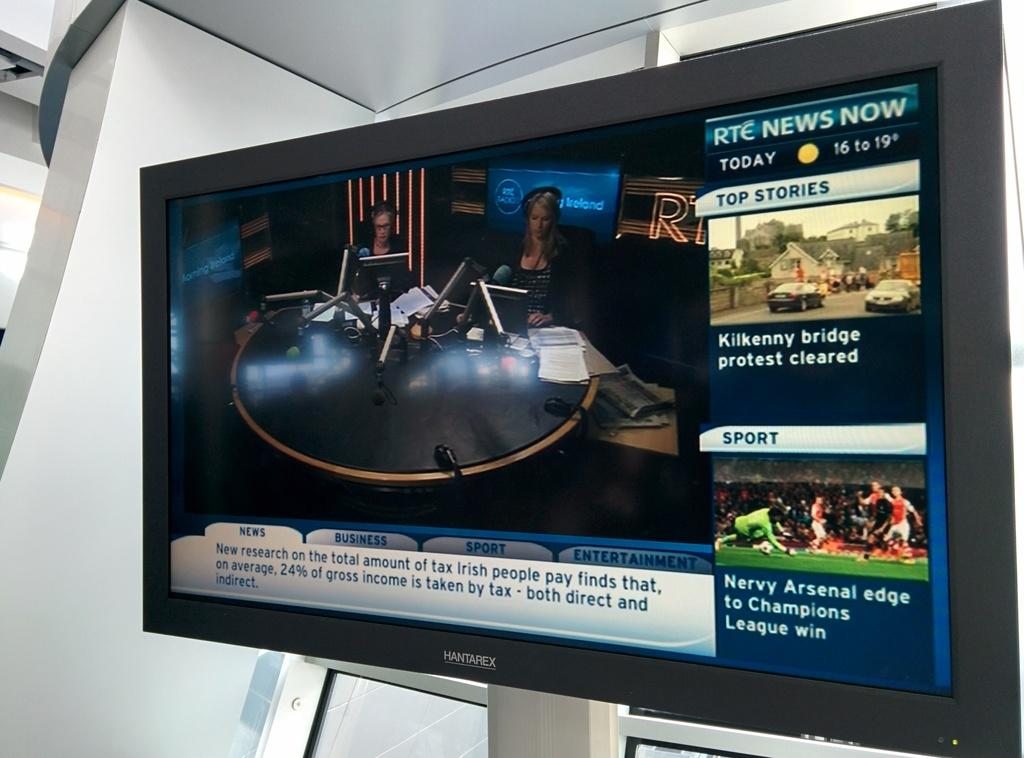Provide a one-sentence caption for the provided image. A news boradcast on the television with RTC News Now written in the top right. 